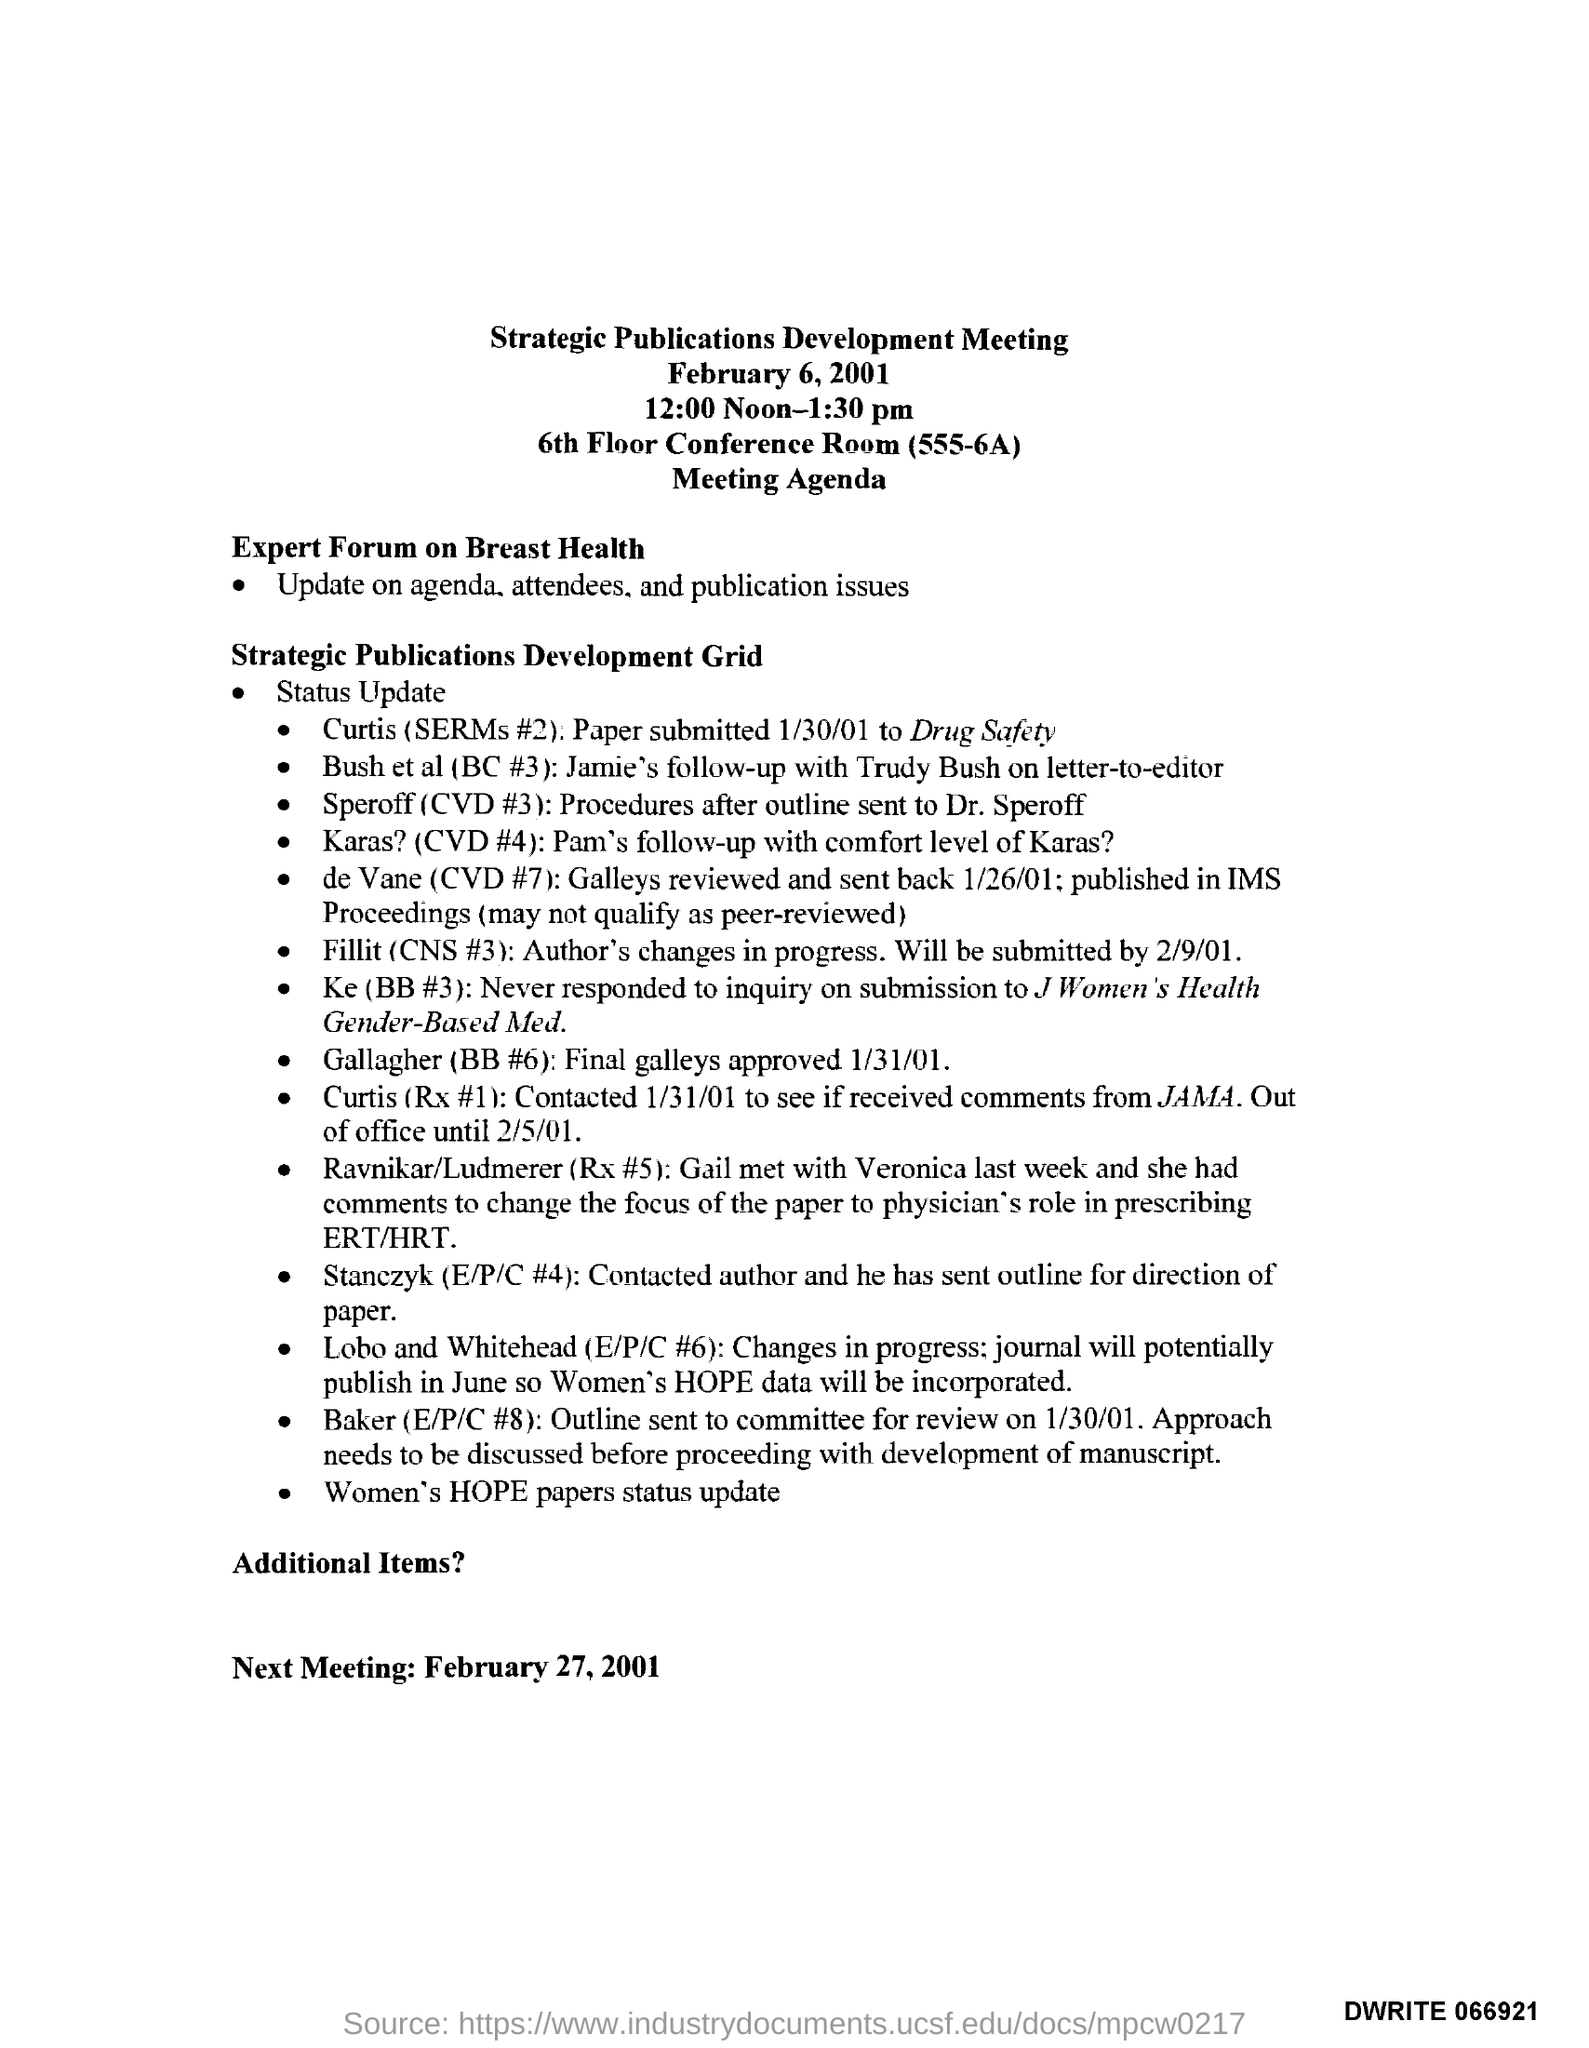When is the Strategic Publications Development Meeting held?
Offer a very short reply. February 6, 2001. What time is the Strategic Publications Development Meeting scheduled?
Provide a short and direct response. 12:00 Noon-1:30 pm. In which place, the Strategic Publications Development Meeting is organized?
Offer a terse response. 6th Floor Conference Room (555-6A). What updates does the Expert forum on Breast Health provide?
Your answer should be very brief. Update on agenda,attendees and publication issues. 